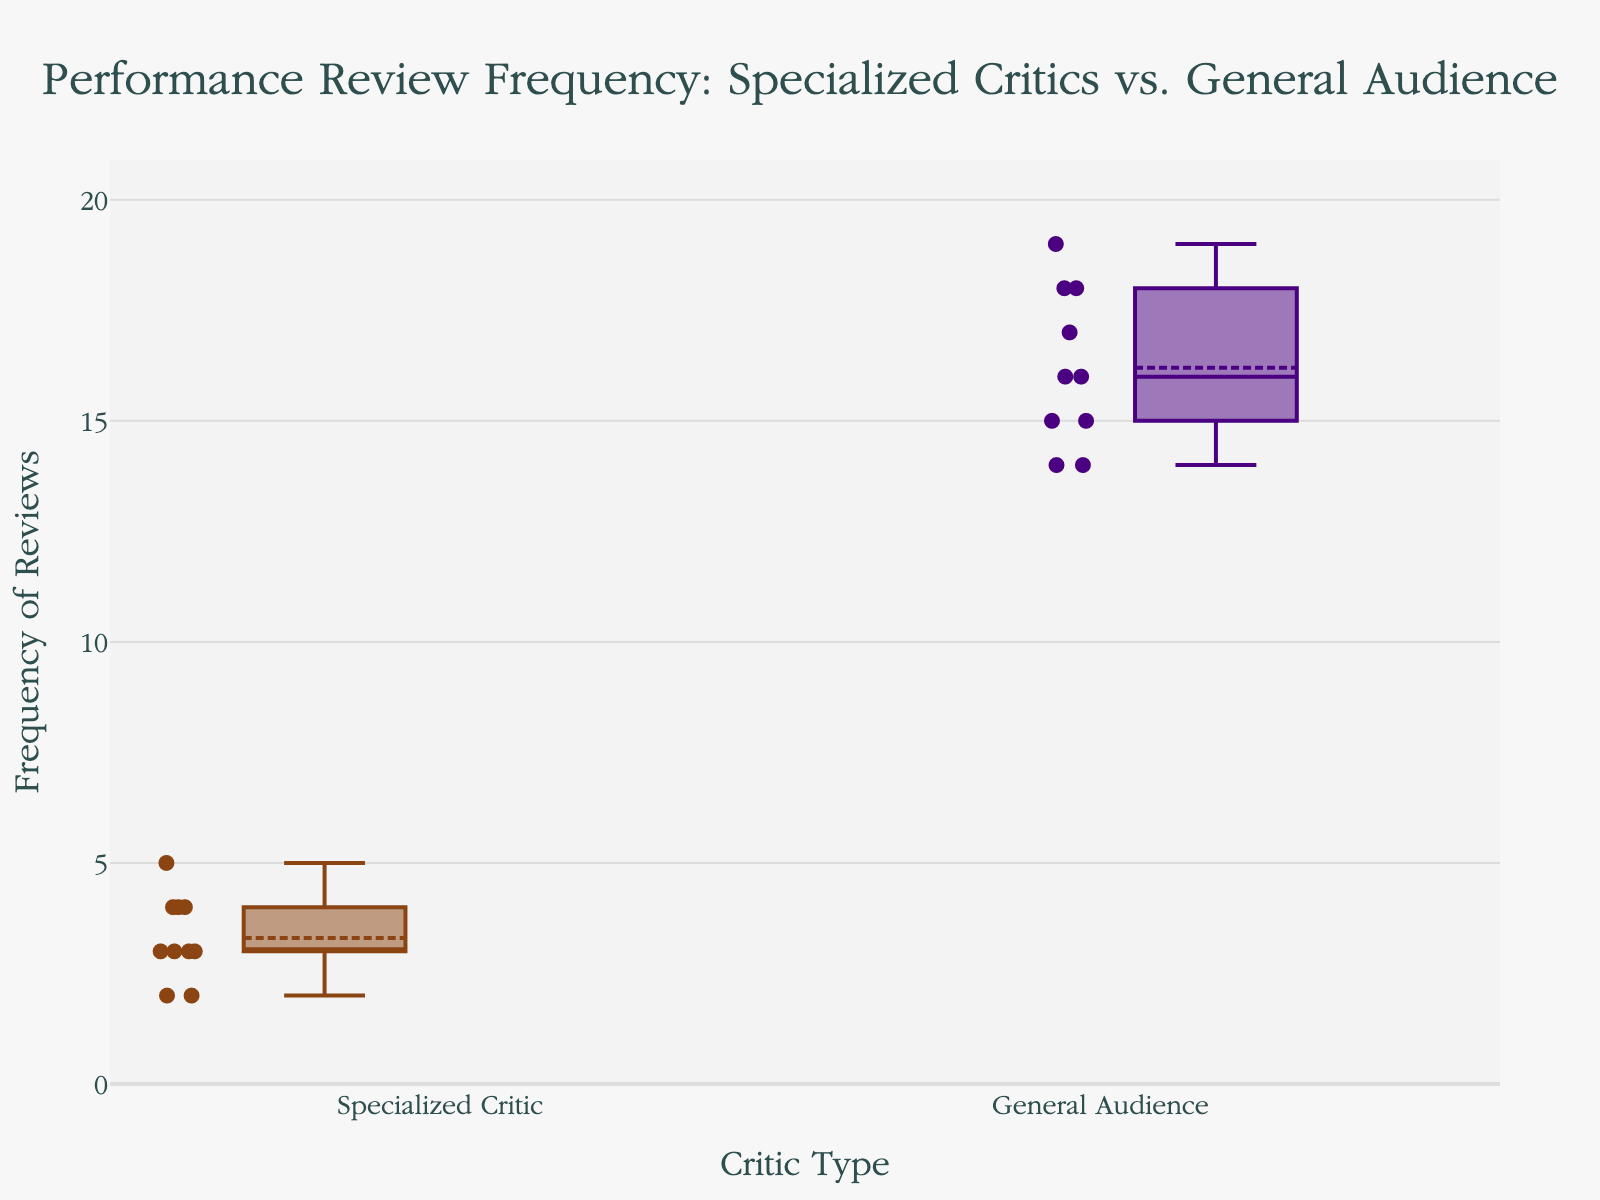What's the title of the plot? The title of the plot is typically located at the top center of the figure. Look at the figure's top area to find it.
Answer: Performance Review Frequency: Specialized Critics vs. General Audience What are the two groups compared in the plot? Check the category names on the x-axis or labels within the plot to identify the groups.
Answer: Specialized Critics and General Audience What is the median frequency of performance reviews by specialized critics? The median is indicated by the line inside the box for the Specialized Critics group. Observe this line and note its position on the y-axis.
Answer: 3 Which group has a higher median frequency of performance reviews? Compare the median lines (the lines inside the boxes) for both groups.
Answer: General Audience What is the range of review frequencies for the General Audience? The range is the difference between the maximum and minimum values. Find the top and bottom "whiskers" of the General Audience box and subtract the lower value from the higher value.
Answer: 5 (19 - 14) How does the variability in review frequency compare between the two groups? Variability can be assessed by the interquartile range (IQR), which is the length of the box. Compare the lengths of the boxes for both groups.
Answer: General Audience has higher variability What is the average frequency of reviews by the general audience? The average (mean) can be inferred from the box plot mean indicators. Look at the dot or line used to show the mean in the General Audience box.
Answer: Approximately 16.2 Is there any overlap in the interquartile ranges (IQR) between the two groups? Observe where the IQR boxes (middle 50% range) of both groups are positioned. Check if any part of one box overlaps with the other.
Answer: No Are there any outliers in the data? Outliers are typically shown as individual points outside the "whiskers" of the box plot. Look for these points in both groups.
Answer: No What is the maximum review frequency by specialized critics? The maximum value is shown by the top "whisker" in the Specialized Critics box. Locate this whisker and note its value on the y-axis.
Answer: 5 